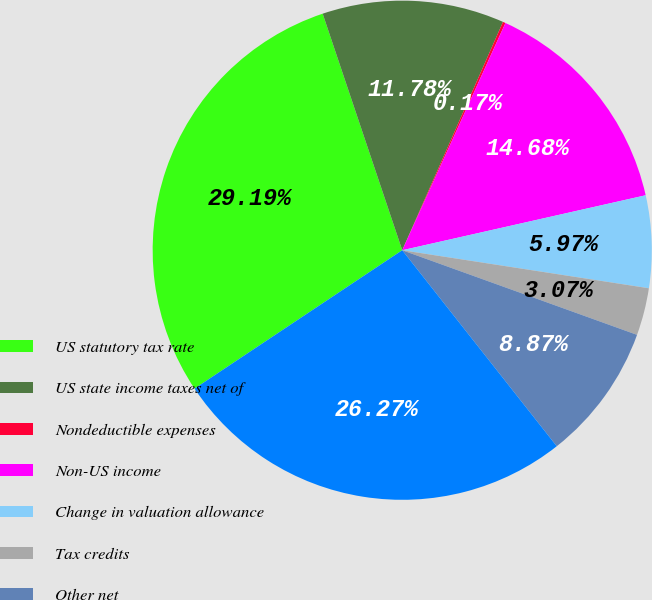<chart> <loc_0><loc_0><loc_500><loc_500><pie_chart><fcel>US statutory tax rate<fcel>US state income taxes net of<fcel>Nondeductible expenses<fcel>Non-US income<fcel>Change in valuation allowance<fcel>Tax credits<fcel>Other net<fcel>Effective rate<nl><fcel>29.19%<fcel>11.78%<fcel>0.17%<fcel>14.68%<fcel>5.97%<fcel>3.07%<fcel>8.87%<fcel>26.27%<nl></chart> 